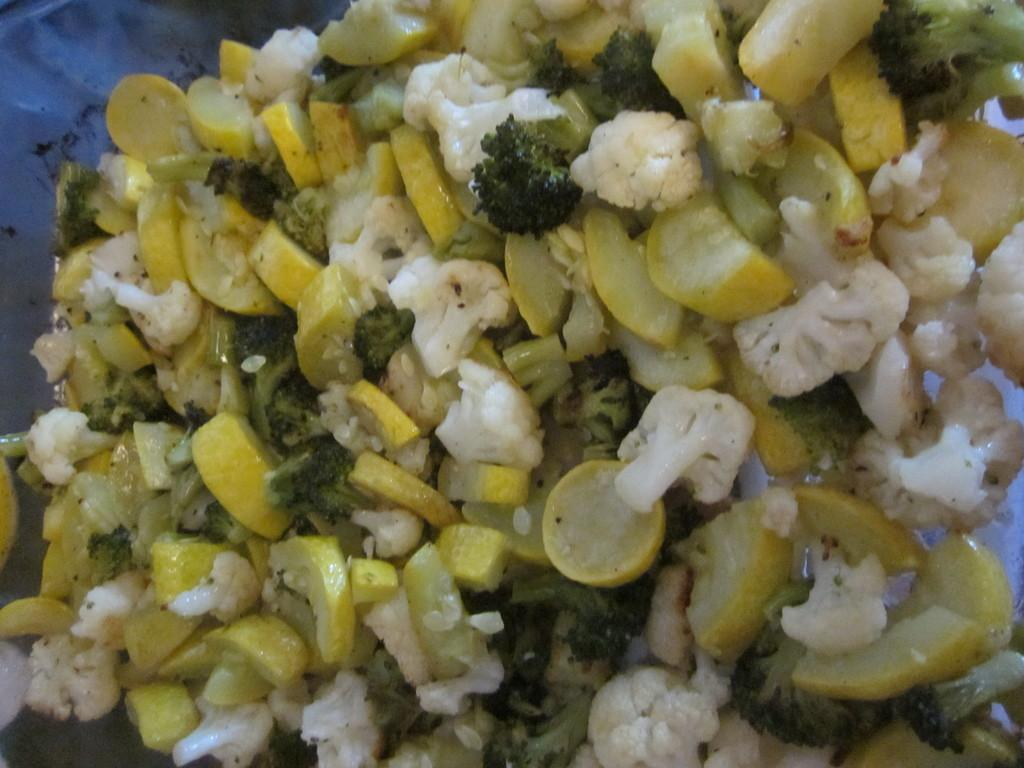What can be seen in the image related to food? There is some food visible in the image. What type of net is being used to catch the food in the image? There is no net present in the image, and the food is not being caught. 